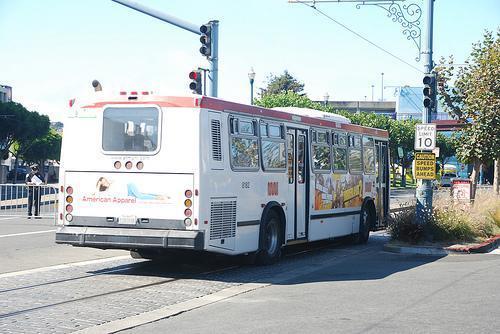How many buses are in the picture?
Give a very brief answer. 1. 